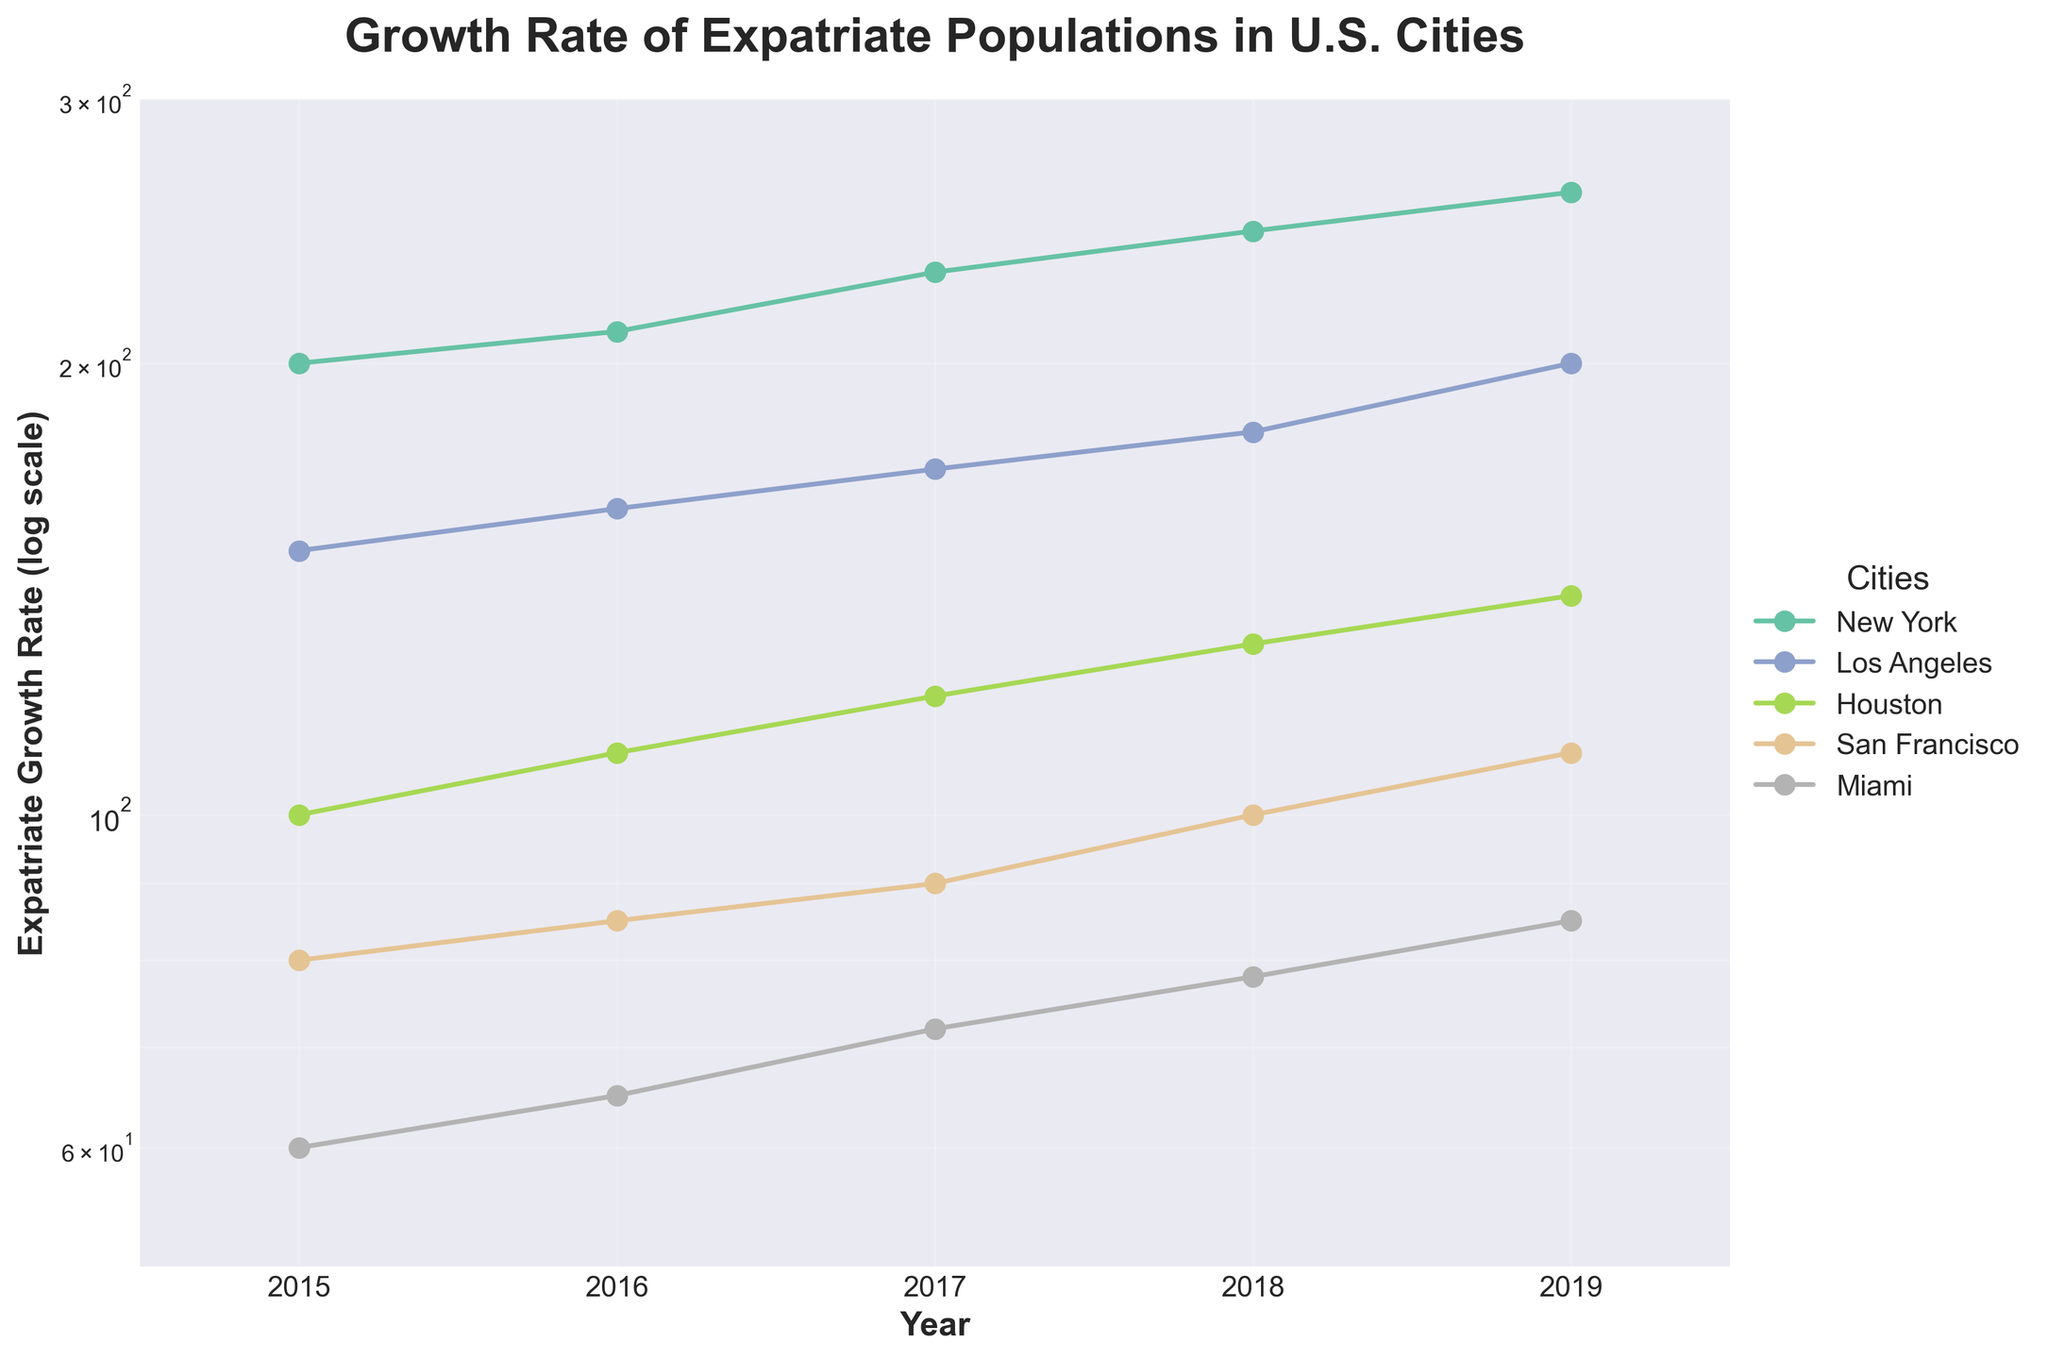How many cities are represented in the plot? There are five distinct colors, each representing a different city.
Answer: 5 Which city had the highest expatriate growth rate in 2019? By looking at the highest data point on the y-axis for the year 2019, New York had the highest growth rate.
Answer: New York How did the expatriate growth rates of San Francisco and Miami compare in 2015? San Francisco had a growth rate of 80 in 2015, while Miami had a growth rate of 60, making San Francisco's rate higher.
Answer: San Francisco was higher What is the general trend of expatriate growth rates for Houston from 2015 to 2019? Observing the plot for Houston, the expatriate growth rates increase each year from 2015 to 2019.
Answer: Increasing Which city showed the steepest growth in expatriate population between 2015 and 2019? By visually comparing the slopes, New York had the steepest upward trend.
Answer: New York What is the minimum expatriate growth rate shown on the y-axis? The log-scaled y-axis starts at 50, which is the minimum value shown.
Answer: 50 By how much did Los Angeles' expatriate growth rate increase from 2015 to 2019? The rate in 2015 was 150, and in 2019 it was 200. The increase is 200 - 150 = 50.
Answer: 50 What is the title of the plot? The title at the top of the plot reads "Growth Rate of Expatriate Populations in U.S. Cities."
Answer: "Growth Rate of Expatriate Populations in U.S. Cities" Which city had the lowest expatriate growth rate in 2018? Miami had the lowest growth rate in 2018, with a value of 78.
Answer: Miami How does the growth rate of expatriates in Los Angeles compare to that in Houston for 2017? Los Angeles had a growth rate of 170, while Houston had a rate of 120 in 2017. Los Angeles was higher.
Answer: Los Angeles was higher 